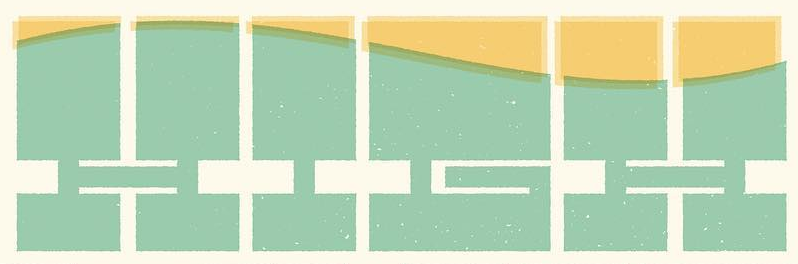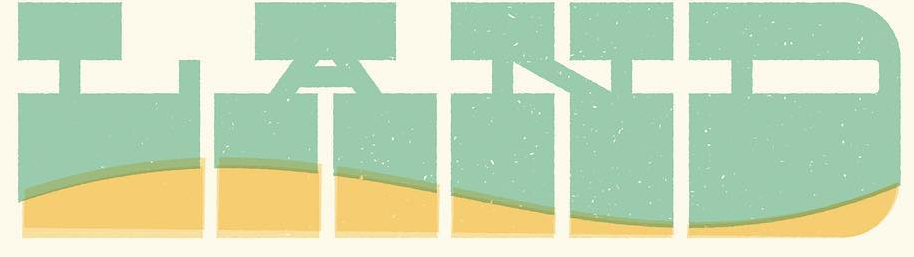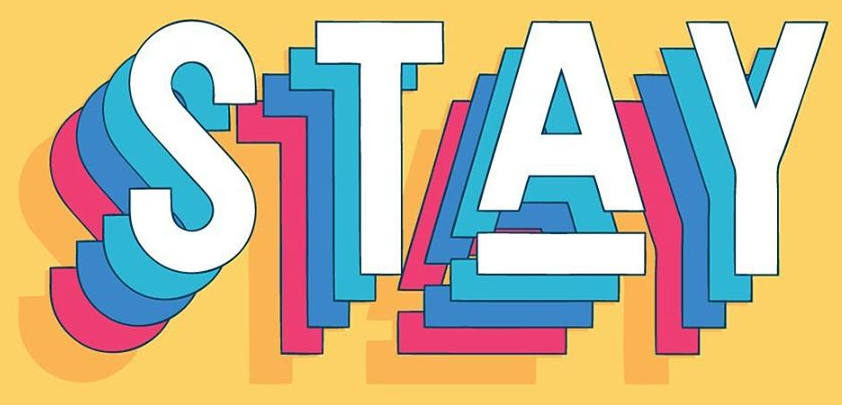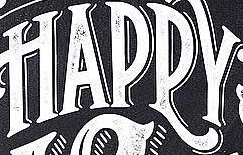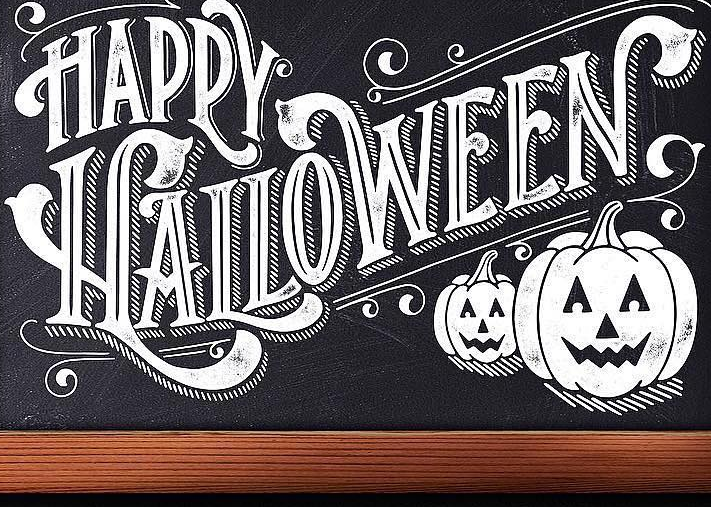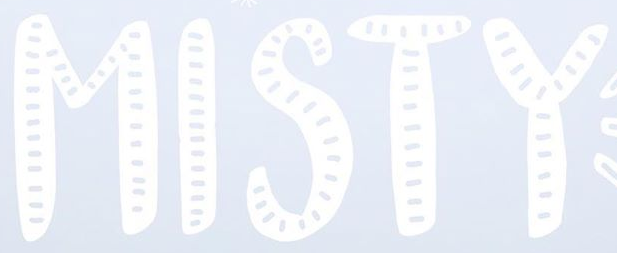What words are shown in these images in order, separated by a semicolon? HIGH; LAND; STAY; HAPPY; HALLOWEEN; MISTY 